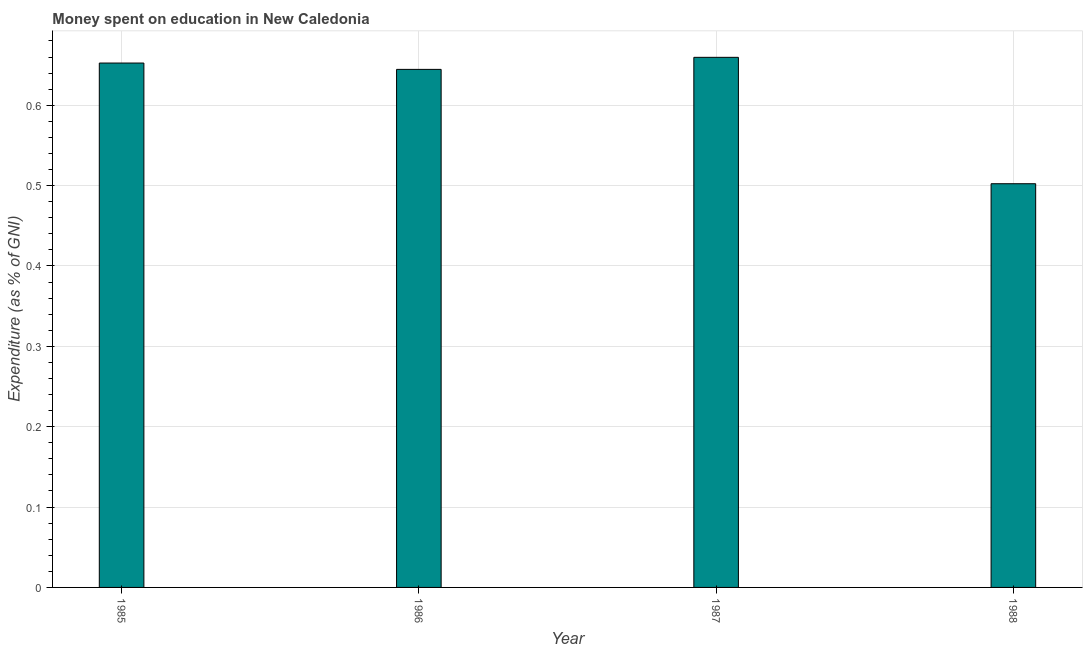Does the graph contain any zero values?
Provide a succinct answer. No. Does the graph contain grids?
Provide a short and direct response. Yes. What is the title of the graph?
Make the answer very short. Money spent on education in New Caledonia. What is the label or title of the X-axis?
Offer a terse response. Year. What is the label or title of the Y-axis?
Keep it short and to the point. Expenditure (as % of GNI). What is the expenditure on education in 1985?
Provide a short and direct response. 0.65. Across all years, what is the maximum expenditure on education?
Make the answer very short. 0.66. Across all years, what is the minimum expenditure on education?
Provide a short and direct response. 0.5. In which year was the expenditure on education maximum?
Your response must be concise. 1987. What is the sum of the expenditure on education?
Give a very brief answer. 2.46. What is the difference between the expenditure on education in 1985 and 1988?
Offer a very short reply. 0.15. What is the average expenditure on education per year?
Provide a short and direct response. 0.61. What is the median expenditure on education?
Offer a very short reply. 0.65. Do a majority of the years between 1986 and 1987 (inclusive) have expenditure on education greater than 0.08 %?
Give a very brief answer. Yes. What is the ratio of the expenditure on education in 1987 to that in 1988?
Keep it short and to the point. 1.31. Is the difference between the expenditure on education in 1985 and 1988 greater than the difference between any two years?
Offer a terse response. No. What is the difference between the highest and the second highest expenditure on education?
Provide a short and direct response. 0.01. What is the difference between the highest and the lowest expenditure on education?
Your answer should be compact. 0.16. How many bars are there?
Your response must be concise. 4. Are the values on the major ticks of Y-axis written in scientific E-notation?
Your answer should be compact. No. What is the Expenditure (as % of GNI) of 1985?
Offer a terse response. 0.65. What is the Expenditure (as % of GNI) of 1986?
Offer a very short reply. 0.64. What is the Expenditure (as % of GNI) in 1987?
Your answer should be compact. 0.66. What is the Expenditure (as % of GNI) of 1988?
Offer a terse response. 0.5. What is the difference between the Expenditure (as % of GNI) in 1985 and 1986?
Your answer should be compact. 0.01. What is the difference between the Expenditure (as % of GNI) in 1985 and 1987?
Your response must be concise. -0.01. What is the difference between the Expenditure (as % of GNI) in 1985 and 1988?
Your answer should be compact. 0.15. What is the difference between the Expenditure (as % of GNI) in 1986 and 1987?
Your answer should be compact. -0.01. What is the difference between the Expenditure (as % of GNI) in 1986 and 1988?
Your answer should be compact. 0.14. What is the difference between the Expenditure (as % of GNI) in 1987 and 1988?
Offer a terse response. 0.16. What is the ratio of the Expenditure (as % of GNI) in 1985 to that in 1987?
Ensure brevity in your answer.  0.99. What is the ratio of the Expenditure (as % of GNI) in 1985 to that in 1988?
Offer a terse response. 1.3. What is the ratio of the Expenditure (as % of GNI) in 1986 to that in 1987?
Ensure brevity in your answer.  0.98. What is the ratio of the Expenditure (as % of GNI) in 1986 to that in 1988?
Your answer should be very brief. 1.28. What is the ratio of the Expenditure (as % of GNI) in 1987 to that in 1988?
Make the answer very short. 1.31. 